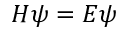<formula> <loc_0><loc_0><loc_500><loc_500>H \psi = E \psi</formula> 